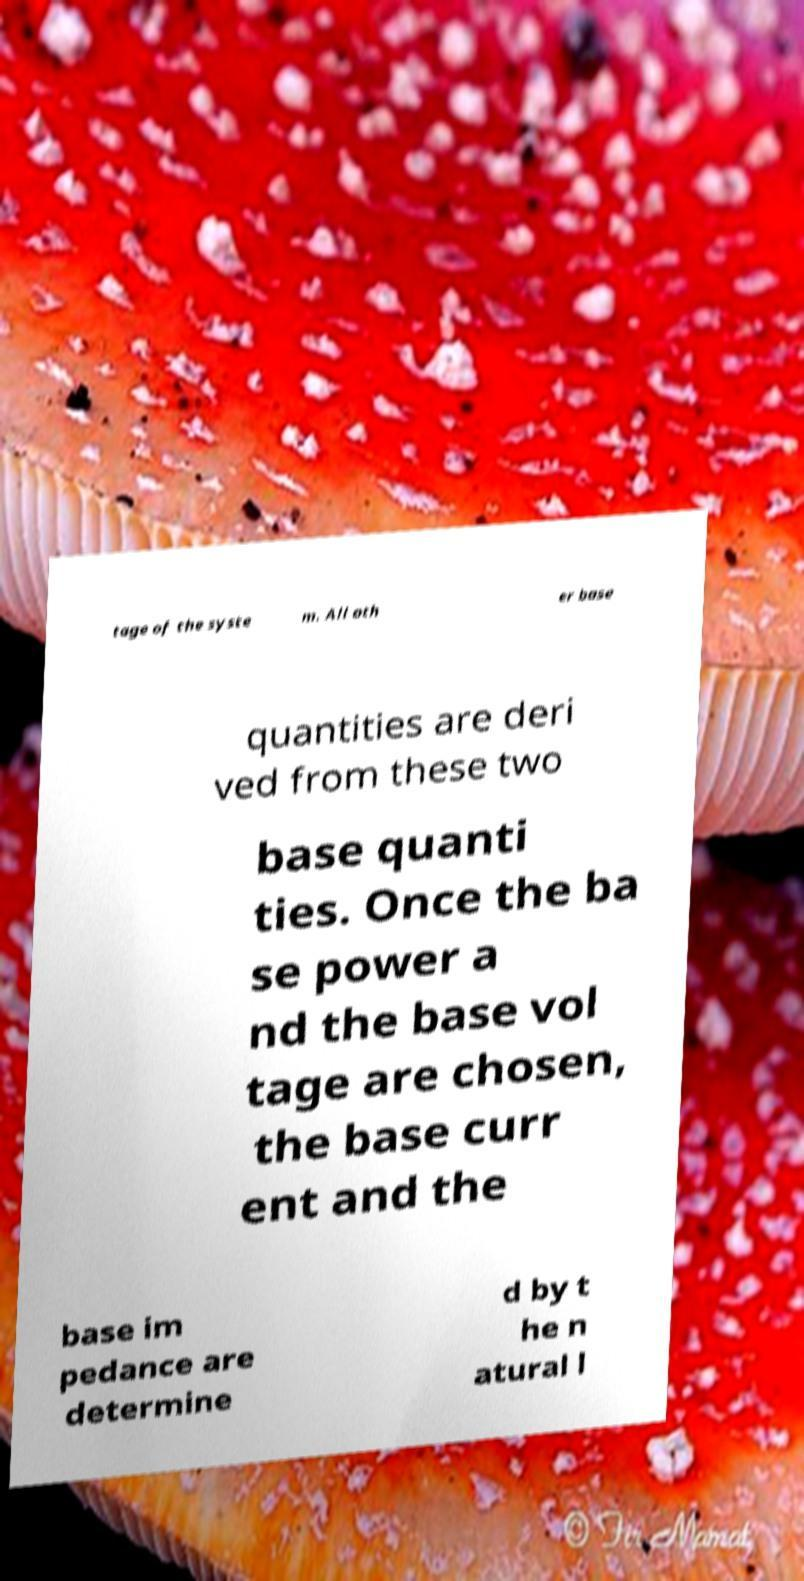Can you read and provide the text displayed in the image?This photo seems to have some interesting text. Can you extract and type it out for me? tage of the syste m. All oth er base quantities are deri ved from these two base quanti ties. Once the ba se power a nd the base vol tage are chosen, the base curr ent and the base im pedance are determine d by t he n atural l 